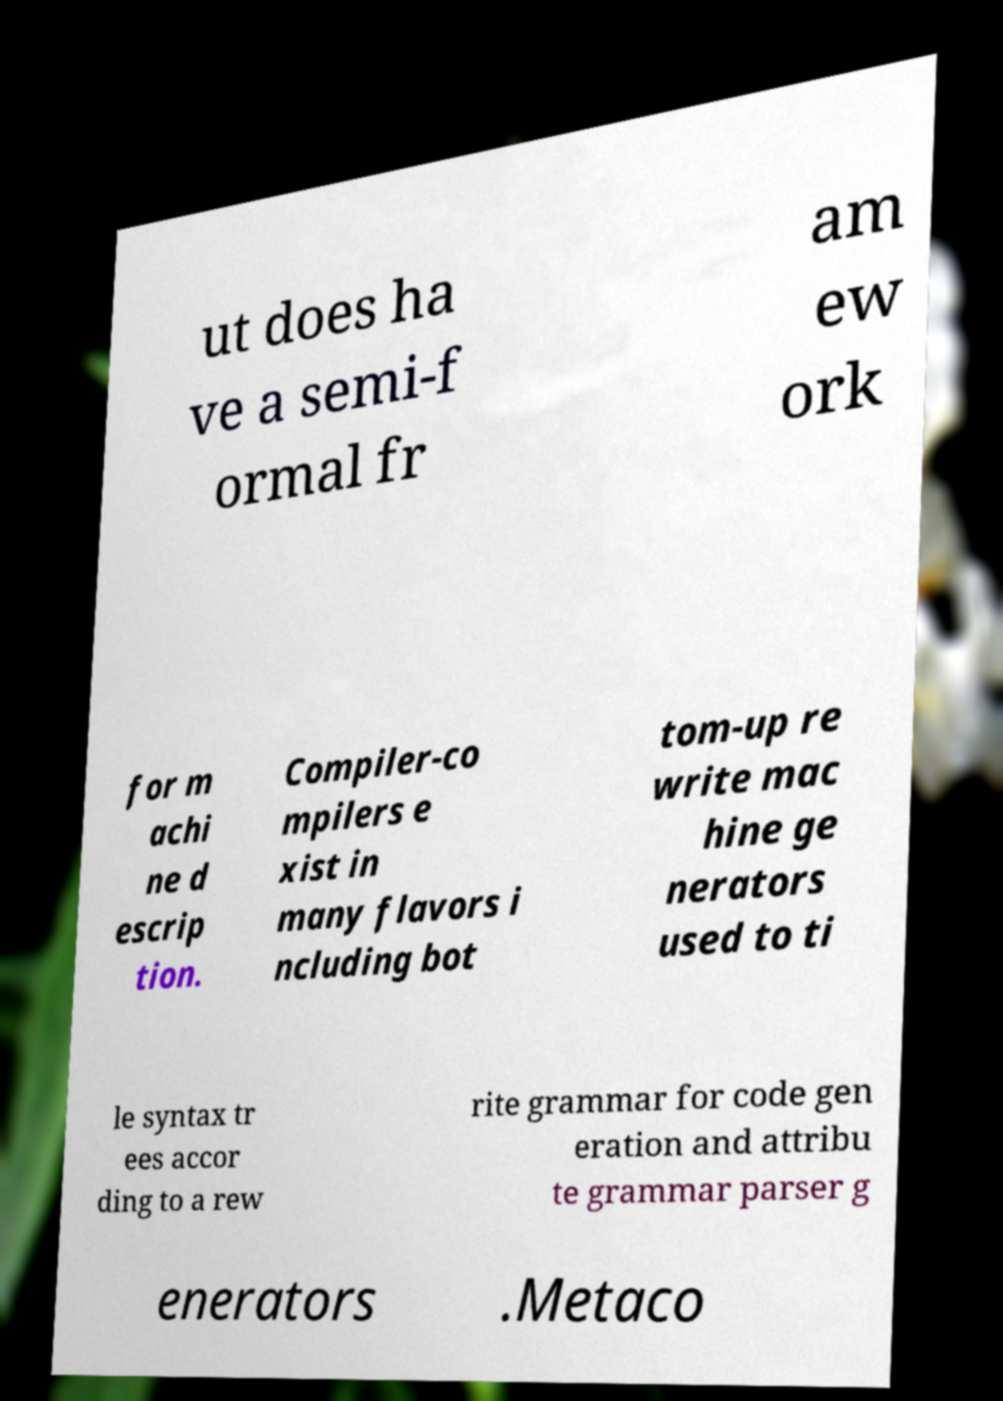Could you extract and type out the text from this image? ut does ha ve a semi-f ormal fr am ew ork for m achi ne d escrip tion. Compiler-co mpilers e xist in many flavors i ncluding bot tom-up re write mac hine ge nerators used to ti le syntax tr ees accor ding to a rew rite grammar for code gen eration and attribu te grammar parser g enerators .Metaco 